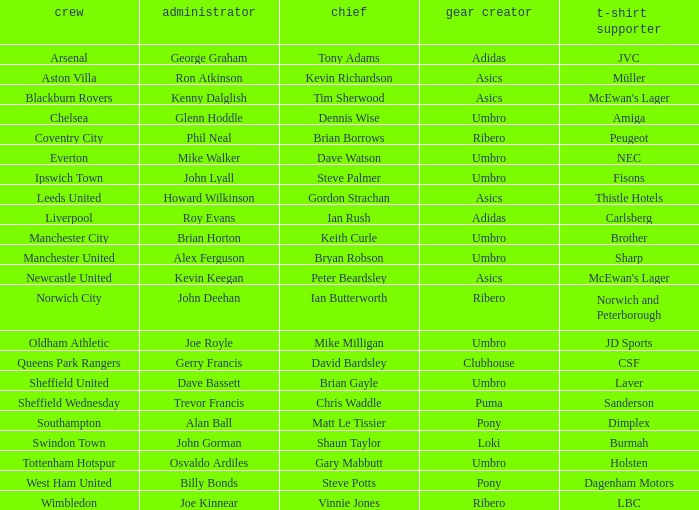Which manager has sheffield wednesday as the team? Trevor Francis. 